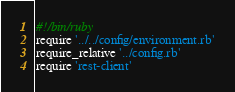Convert code to text. <code><loc_0><loc_0><loc_500><loc_500><_Ruby_>#!/bin/ruby
require '../../config/environment.rb'
require_relative '../config.rb'
require 'rest-client'</code> 